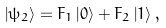Convert formula to latex. <formula><loc_0><loc_0><loc_500><loc_500>\left | \psi _ { 2 } \right \rangle = F _ { 1 } \left | 0 \right \rangle + F _ { 2 } \left | 1 \right \rangle ,</formula> 